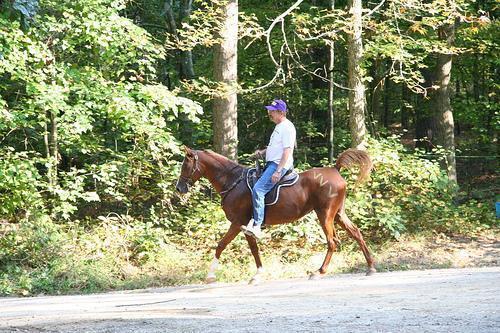How many legs does the horse have?
Give a very brief answer. 4. 